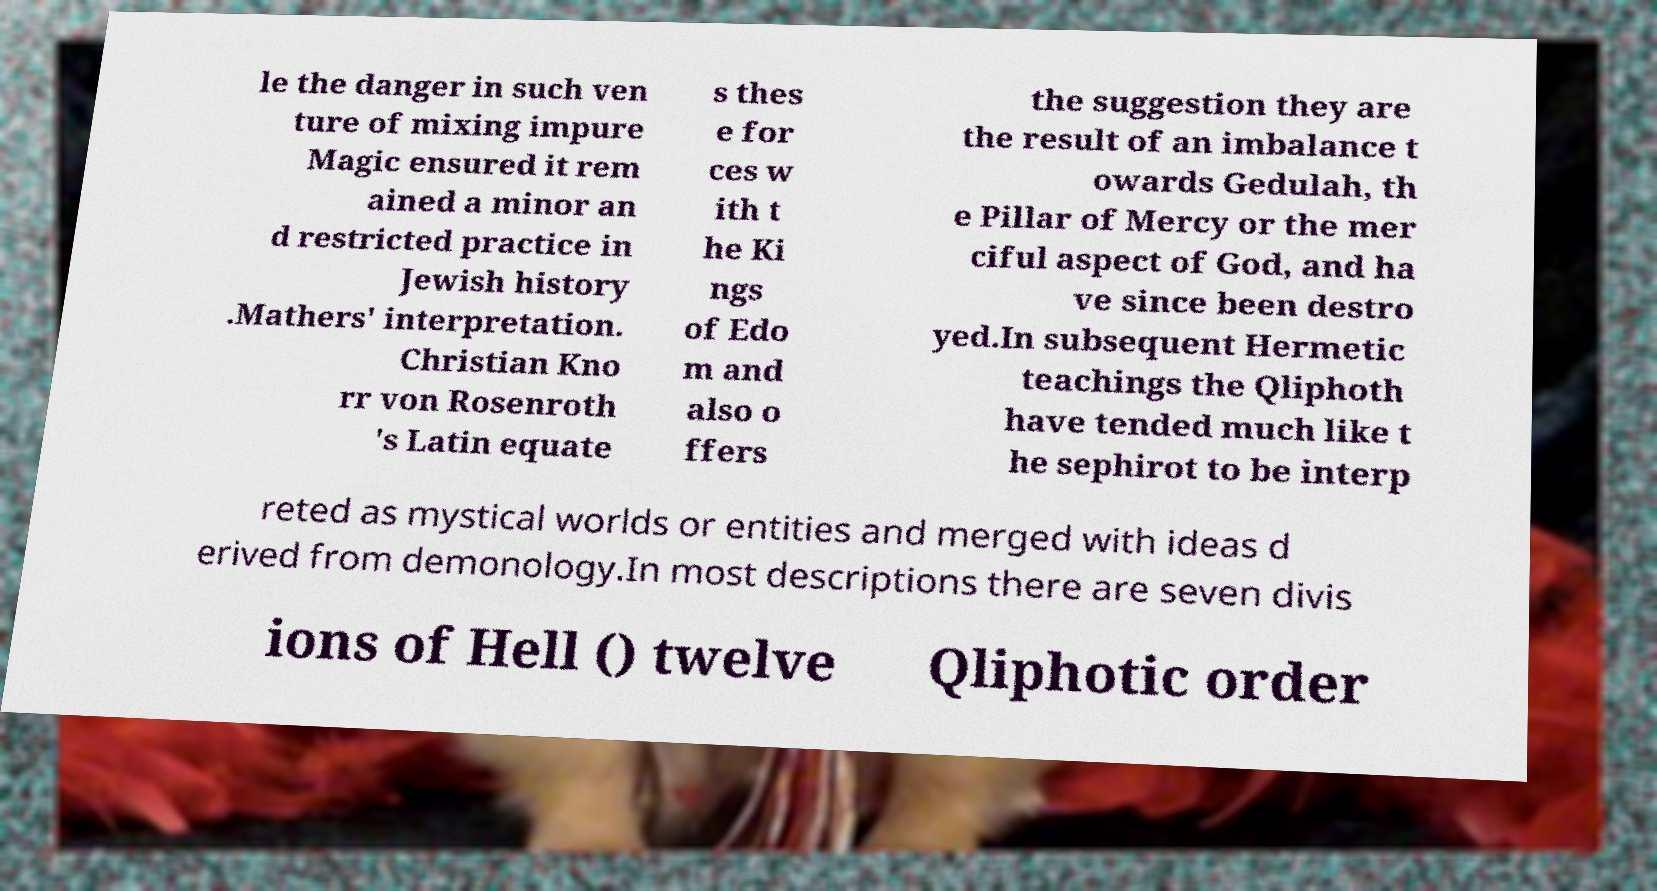Could you extract and type out the text from this image? le the danger in such ven ture of mixing impure Magic ensured it rem ained a minor an d restricted practice in Jewish history .Mathers' interpretation. Christian Kno rr von Rosenroth 's Latin equate s thes e for ces w ith t he Ki ngs of Edo m and also o ffers the suggestion they are the result of an imbalance t owards Gedulah, th e Pillar of Mercy or the mer ciful aspect of God, and ha ve since been destro yed.In subsequent Hermetic teachings the Qliphoth have tended much like t he sephirot to be interp reted as mystical worlds or entities and merged with ideas d erived from demonology.In most descriptions there are seven divis ions of Hell () twelve Qliphotic order 